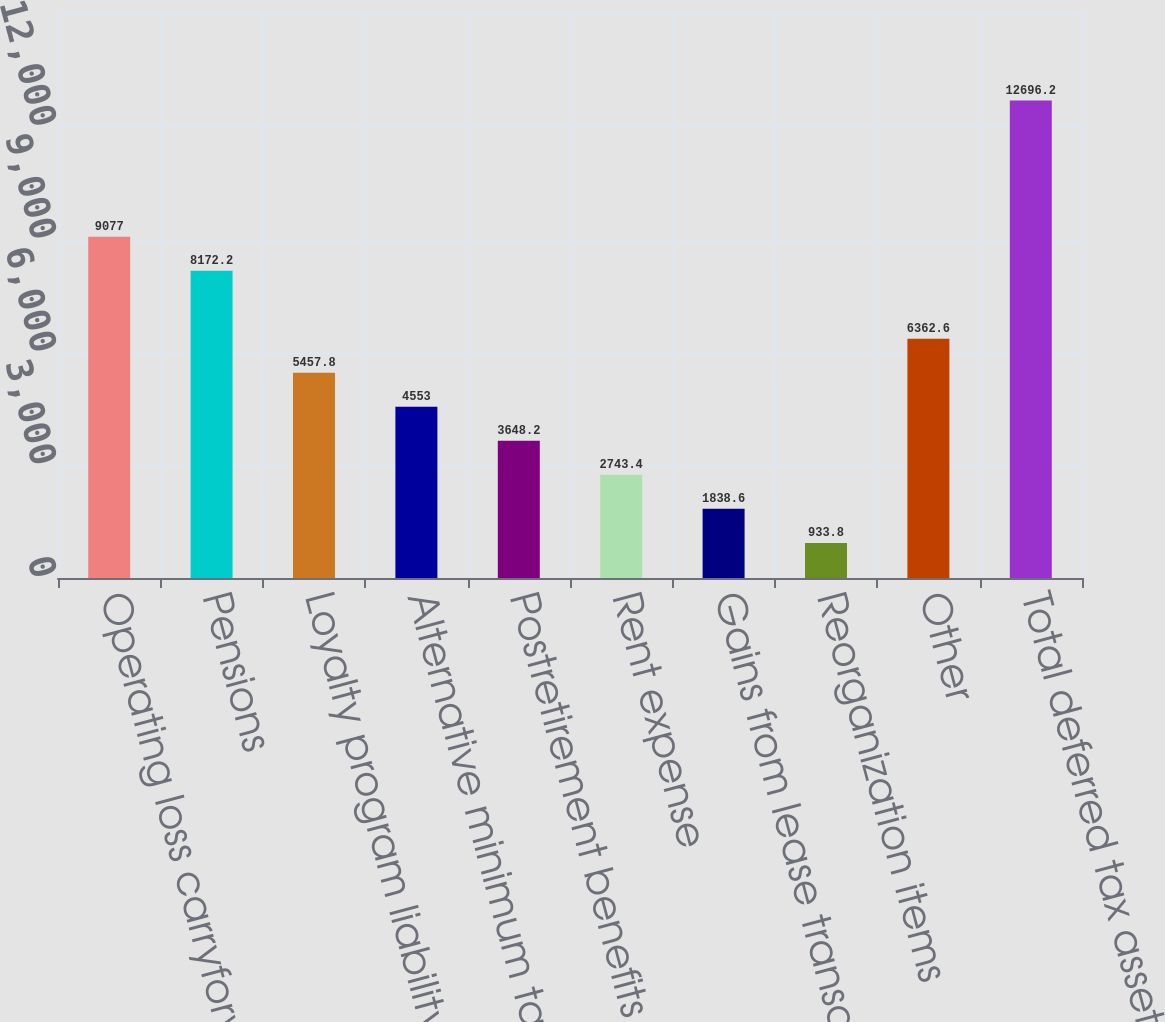Convert chart. <chart><loc_0><loc_0><loc_500><loc_500><bar_chart><fcel>Operating loss carryforwards<fcel>Pensions<fcel>Loyalty program liability<fcel>Alternative minimum tax credit<fcel>Postretirement benefits other<fcel>Rent expense<fcel>Gains from lease transactions<fcel>Reorganization items<fcel>Other<fcel>Total deferred tax assets<nl><fcel>9077<fcel>8172.2<fcel>5457.8<fcel>4553<fcel>3648.2<fcel>2743.4<fcel>1838.6<fcel>933.8<fcel>6362.6<fcel>12696.2<nl></chart> 